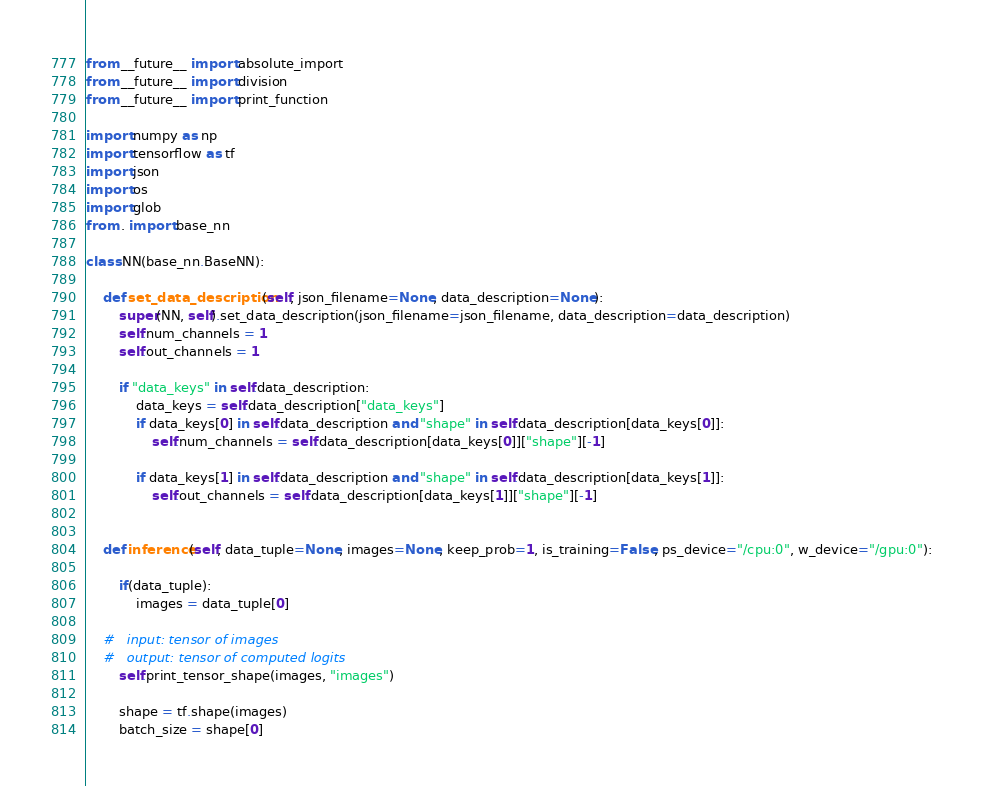Convert code to text. <code><loc_0><loc_0><loc_500><loc_500><_Python_>from __future__ import absolute_import
from __future__ import division
from __future__ import print_function

import numpy as np
import tensorflow as tf
import json
import os
import glob
from . import base_nn

class NN(base_nn.BaseNN):

    def set_data_description(self, json_filename=None, data_description=None):
        super(NN, self).set_data_description(json_filename=json_filename, data_description=data_description)
        self.num_channels = 1
        self.out_channels = 1

        if "data_keys" in self.data_description:
            data_keys = self.data_description["data_keys"]
            if data_keys[0] in self.data_description and "shape" in self.data_description[data_keys[0]]:
                self.num_channels = self.data_description[data_keys[0]]["shape"][-1]

            if data_keys[1] in self.data_description and "shape" in self.data_description[data_keys[1]]:
                self.out_channels = self.data_description[data_keys[1]]["shape"][-1]


    def inference(self, data_tuple=None, images=None, keep_prob=1, is_training=False, ps_device="/cpu:0", w_device="/gpu:0"):

        if(data_tuple):
            images = data_tuple[0]

    #   input: tensor of images
    #   output: tensor of computed logits
        self.print_tensor_shape(images, "images")

        shape = tf.shape(images)
        batch_size = shape[0]
</code> 